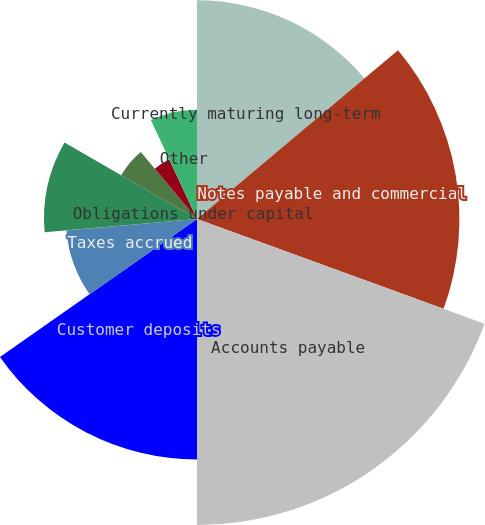Convert chart. <chart><loc_0><loc_0><loc_500><loc_500><pie_chart><fcel>Currently maturing long-term<fcel>Notes payable and commercial<fcel>Accounts payable<fcel>Customer deposits<fcel>Taxes accrued<fcel>Interest accrued<fcel>Deferred fuel costs<fcel>Obligations under capital<fcel>Pension and other<fcel>Other<nl><fcel>13.89%<fcel>16.67%<fcel>19.44%<fcel>15.28%<fcel>8.33%<fcel>9.72%<fcel>5.56%<fcel>0.0%<fcel>4.17%<fcel>6.94%<nl></chart> 